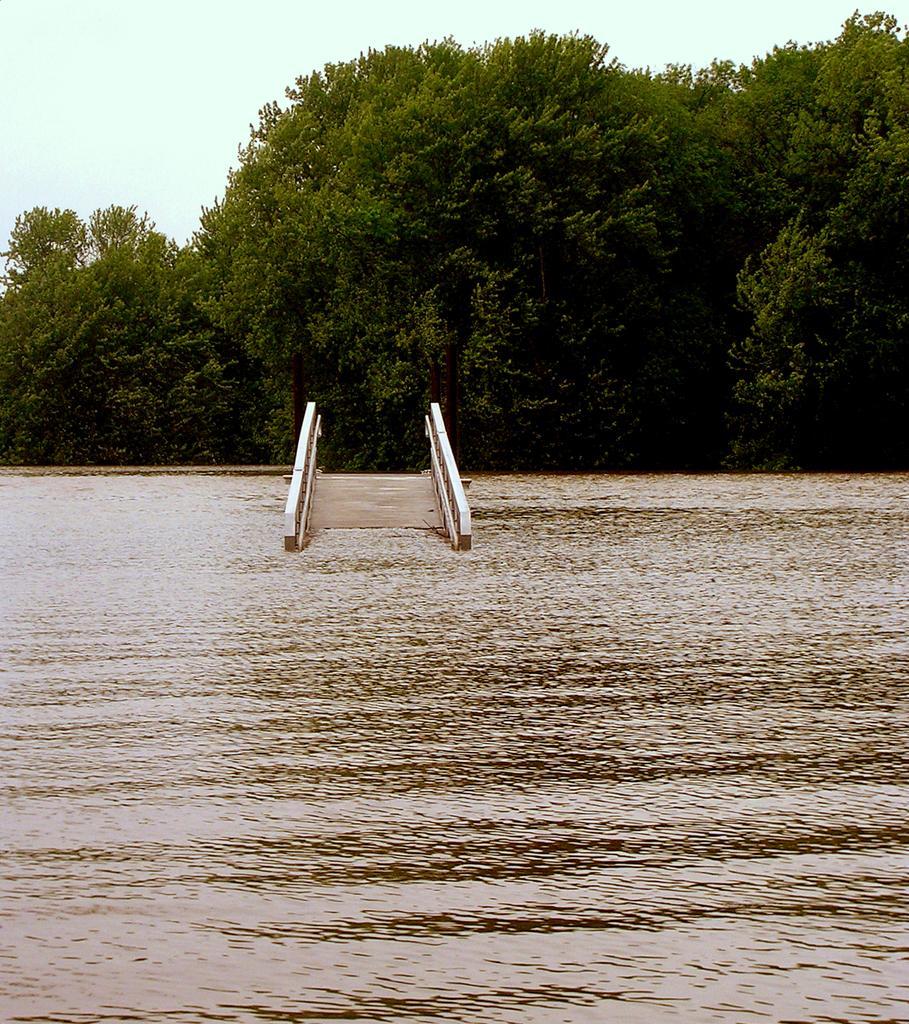Describe this image in one or two sentences. In this image, we can see a bridge in the water. There are some trees in the middle of the image. There is a sky at the top of the image. 